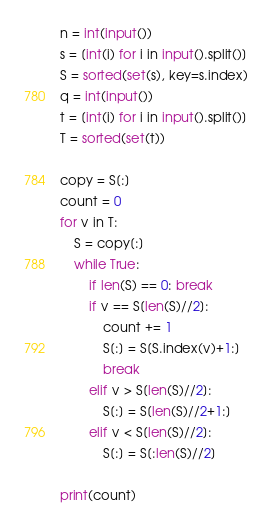Convert code to text. <code><loc_0><loc_0><loc_500><loc_500><_Python_>n = int(input())
s = [int(i) for i in input().split()]
S = sorted(set(s), key=s.index)
q = int(input())
t = [int(i) for i in input().split()]
T = sorted(set(t))

copy = S[:]
count = 0
for v in T:
    S = copy[:]
    while True:
        if len(S) == 0: break
        if v == S[len(S)//2]:
            count += 1
            S[:] = S[S.index(v)+1:]
            break
        elif v > S[len(S)//2]:
            S[:] = S[len(S)//2+1:]
        elif v < S[len(S)//2]:
            S[:] = S[:len(S)//2]

print(count)</code> 